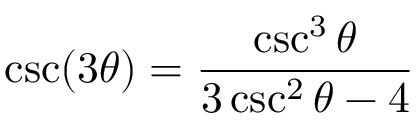<formula> <loc_0><loc_0><loc_500><loc_500>\csc ( 3 \theta ) = { \frac { \csc ^ { 3 } \theta } { 3 \csc ^ { 2 } \theta - 4 } }</formula> 